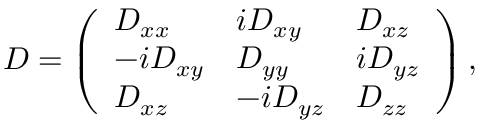Convert formula to latex. <formula><loc_0><loc_0><loc_500><loc_500>D = \left ( \begin{array} { l l l } { D _ { x x } } & { i D _ { x y } } & { D _ { x z } } \\ { - i D _ { x y } } & { D _ { y y } } & { i D _ { y z } } \\ { D _ { x z } } & { - i D _ { y z } } & { D _ { z z } } \end{array} \right ) ,</formula> 